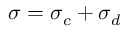<formula> <loc_0><loc_0><loc_500><loc_500>\sigma = \sigma _ { c } + \sigma _ { d }</formula> 